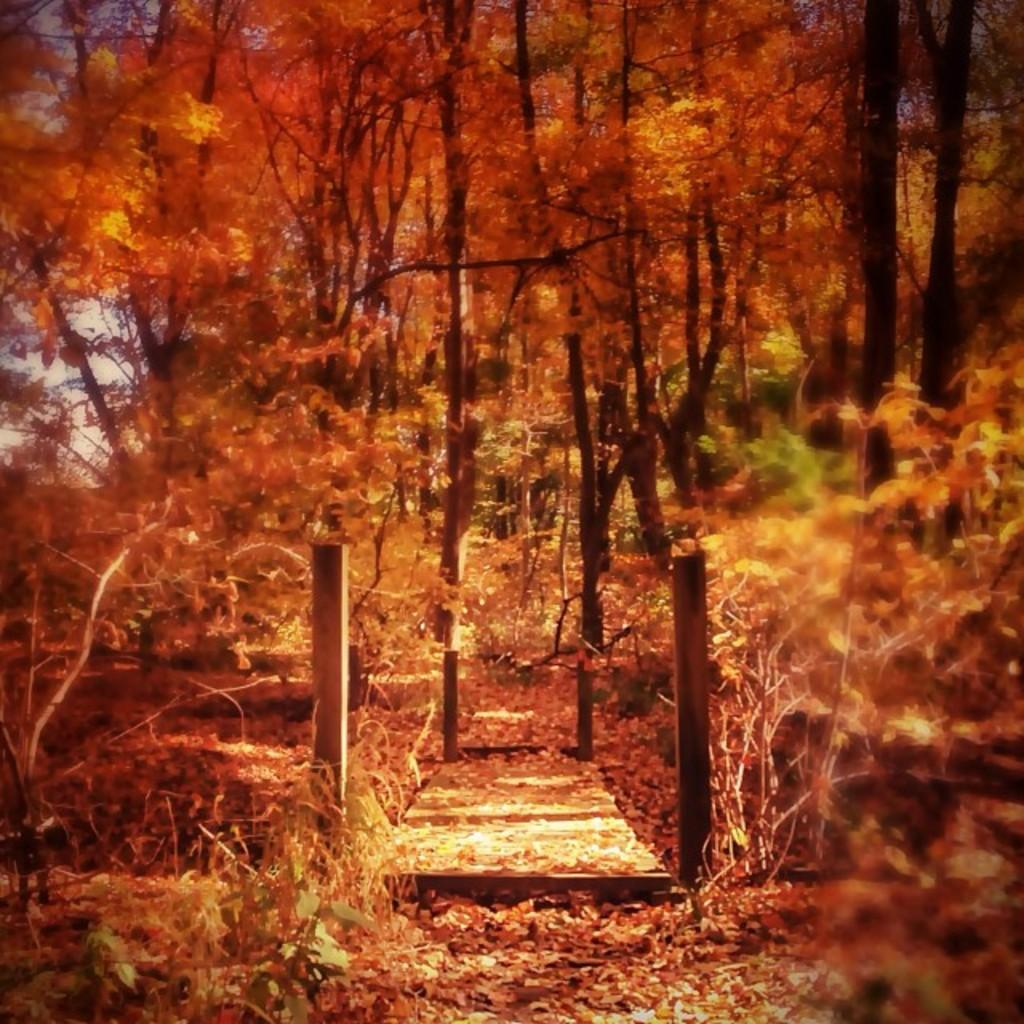What type of trees are present in the image? There are colorful trees in the image. Can you describe any other objects or structures in the image? There is a wooden table visible on the ground in the image. Is there a gold boat sailing on the trail in the image? No, there is no boat or trail present in the image. The image features colorful trees and a wooden table. 